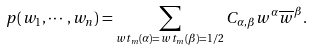Convert formula to latex. <formula><loc_0><loc_0><loc_500><loc_500>p ( w _ { 1 } , \cdots , w _ { n } ) = \sum _ { w t _ { m } ( \alpha ) = w t _ { m } ( \beta ) = 1 / 2 } C _ { \alpha , \beta } w ^ { \alpha } \overline { w } ^ { \beta } .</formula> 